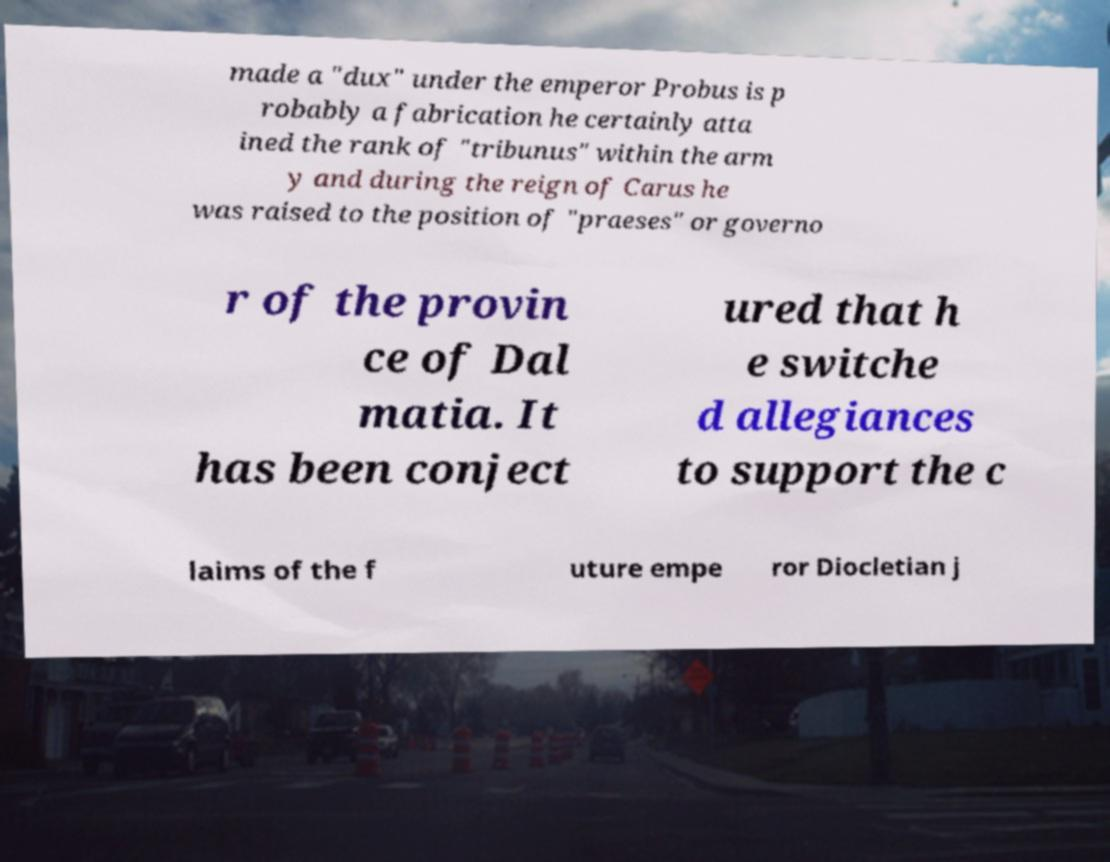Can you accurately transcribe the text from the provided image for me? made a "dux" under the emperor Probus is p robably a fabrication he certainly atta ined the rank of "tribunus" within the arm y and during the reign of Carus he was raised to the position of "praeses" or governo r of the provin ce of Dal matia. It has been conject ured that h e switche d allegiances to support the c laims of the f uture empe ror Diocletian j 